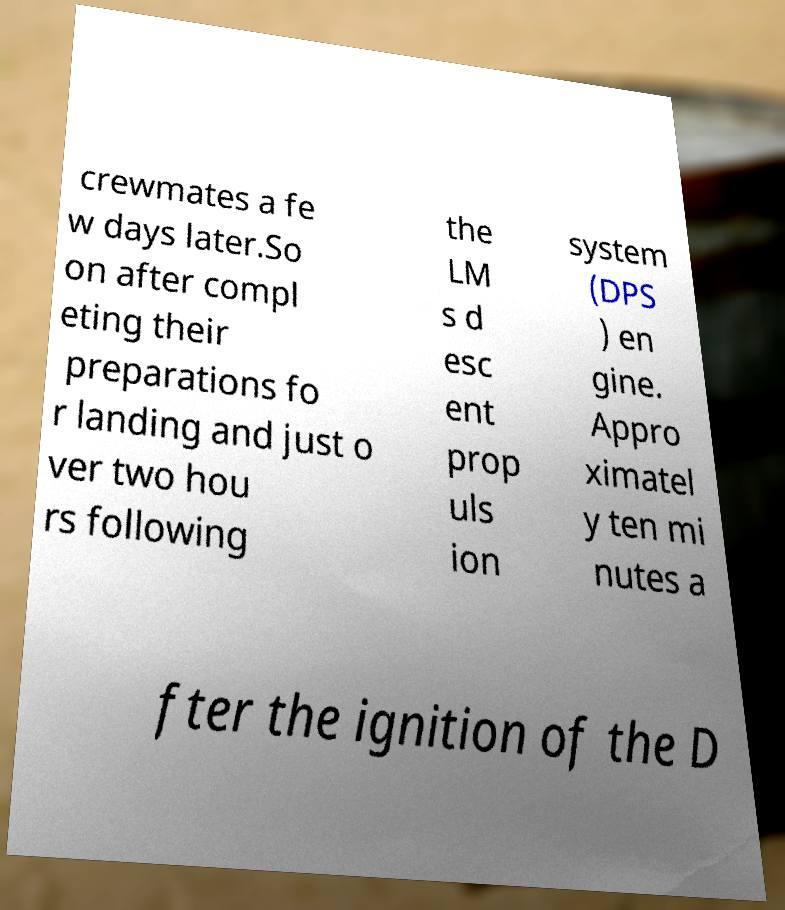Could you assist in decoding the text presented in this image and type it out clearly? crewmates a fe w days later.So on after compl eting their preparations fo r landing and just o ver two hou rs following the LM s d esc ent prop uls ion system (DPS ) en gine. Appro ximatel y ten mi nutes a fter the ignition of the D 